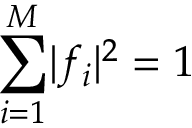<formula> <loc_0><loc_0><loc_500><loc_500>\sum _ { i = 1 } ^ { M } | f _ { i } | ^ { 2 } = 1</formula> 